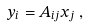Convert formula to latex. <formula><loc_0><loc_0><loc_500><loc_500>y _ { i } = A _ { i j } x _ { j } \, ,</formula> 